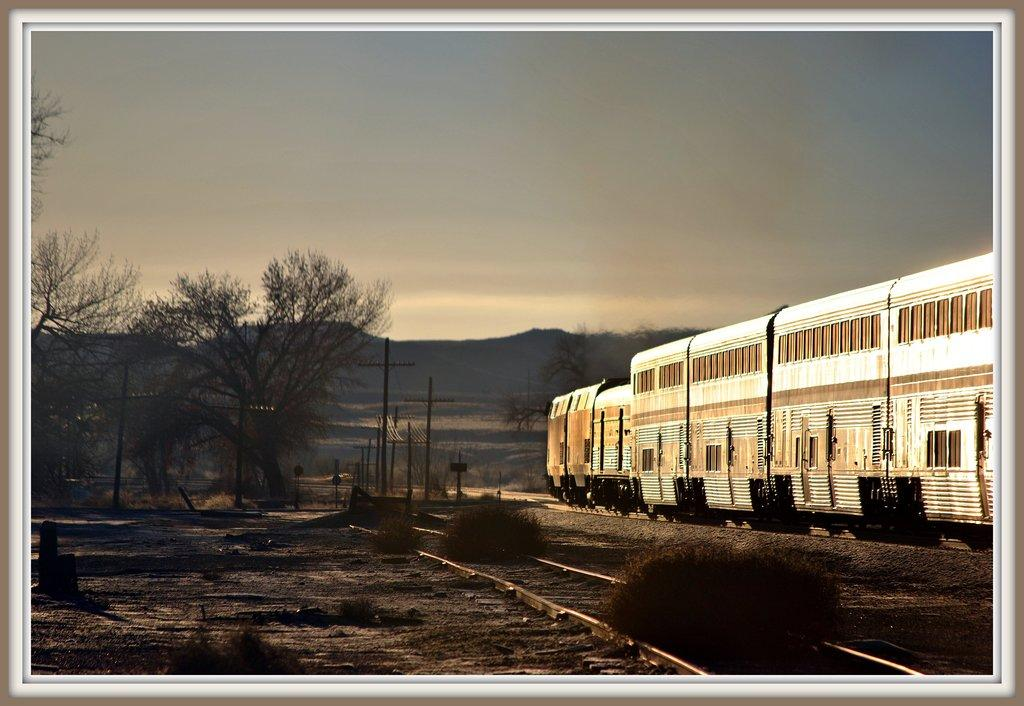What type of surface can be seen in the image? There is ground visible in the image. What is located on the ground in the image? There are railway tracks on the ground. What type of vegetation is present in the image? There are plants, trees, and mountains visible in the image. What structures can be seen in the image? There are poles in the image. What mode of transportation is present in the image? There are trains in the image. What can be seen in the background of the image? There are mountains and the sky visible in the background. What type of liquid can be seen flowing through the mountains in the image? There is no liquid flowing through the mountains in the image; it only shows railway tracks, trains, and vegetation. 